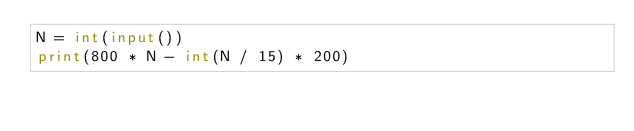Convert code to text. <code><loc_0><loc_0><loc_500><loc_500><_Python_>N = int(input())
print(800 * N - int(N / 15) * 200)</code> 